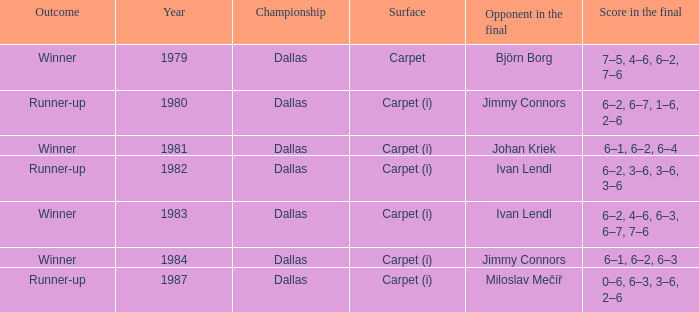How many outcomes are listed when the final opponent was Johan Kriek?  1.0. 